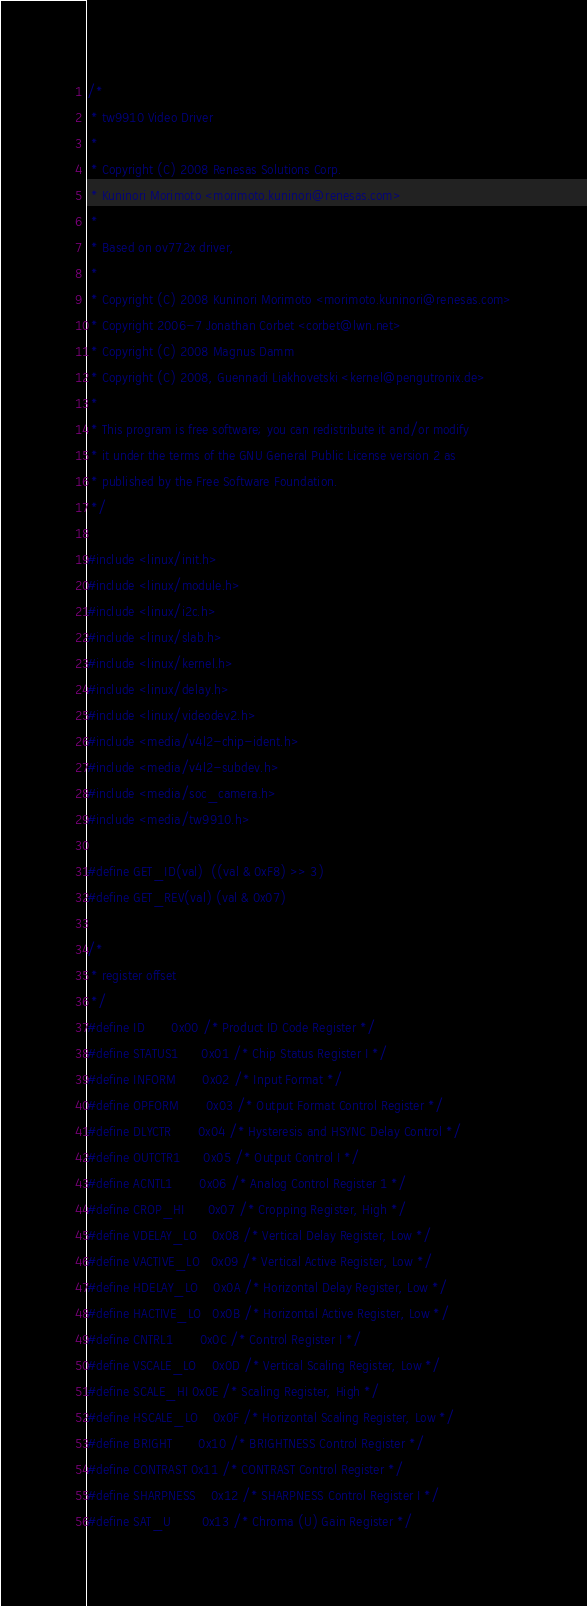Convert code to text. <code><loc_0><loc_0><loc_500><loc_500><_C_>/*
 * tw9910 Video Driver
 *
 * Copyright (C) 2008 Renesas Solutions Corp.
 * Kuninori Morimoto <morimoto.kuninori@renesas.com>
 *
 * Based on ov772x driver,
 *
 * Copyright (C) 2008 Kuninori Morimoto <morimoto.kuninori@renesas.com>
 * Copyright 2006-7 Jonathan Corbet <corbet@lwn.net>
 * Copyright (C) 2008 Magnus Damm
 * Copyright (C) 2008, Guennadi Liakhovetski <kernel@pengutronix.de>
 *
 * This program is free software; you can redistribute it and/or modify
 * it under the terms of the GNU General Public License version 2 as
 * published by the Free Software Foundation.
 */

#include <linux/init.h>
#include <linux/module.h>
#include <linux/i2c.h>
#include <linux/slab.h>
#include <linux/kernel.h>
#include <linux/delay.h>
#include <linux/videodev2.h>
#include <media/v4l2-chip-ident.h>
#include <media/v4l2-subdev.h>
#include <media/soc_camera.h>
#include <media/tw9910.h>

#define GET_ID(val)  ((val & 0xF8) >> 3)
#define GET_REV(val) (val & 0x07)

/*
 * register offset
 */
#define ID		0x00 /* Product ID Code Register */
#define STATUS1		0x01 /* Chip Status Register I */
#define INFORM		0x02 /* Input Format */
#define OPFORM		0x03 /* Output Format Control Register */
#define DLYCTR		0x04 /* Hysteresis and HSYNC Delay Control */
#define OUTCTR1		0x05 /* Output Control I */
#define ACNTL1		0x06 /* Analog Control Register 1 */
#define CROP_HI		0x07 /* Cropping Register, High */
#define VDELAY_LO	0x08 /* Vertical Delay Register, Low */
#define VACTIVE_LO	0x09 /* Vertical Active Register, Low */
#define HDELAY_LO	0x0A /* Horizontal Delay Register, Low */
#define HACTIVE_LO	0x0B /* Horizontal Active Register, Low */
#define CNTRL1		0x0C /* Control Register I */
#define VSCALE_LO	0x0D /* Vertical Scaling Register, Low */
#define SCALE_HI	0x0E /* Scaling Register, High */
#define HSCALE_LO	0x0F /* Horizontal Scaling Register, Low */
#define BRIGHT		0x10 /* BRIGHTNESS Control Register */
#define CONTRAST	0x11 /* CONTRAST Control Register */
#define SHARPNESS	0x12 /* SHARPNESS Control Register I */
#define SAT_U		0x13 /* Chroma (U) Gain Register */</code> 